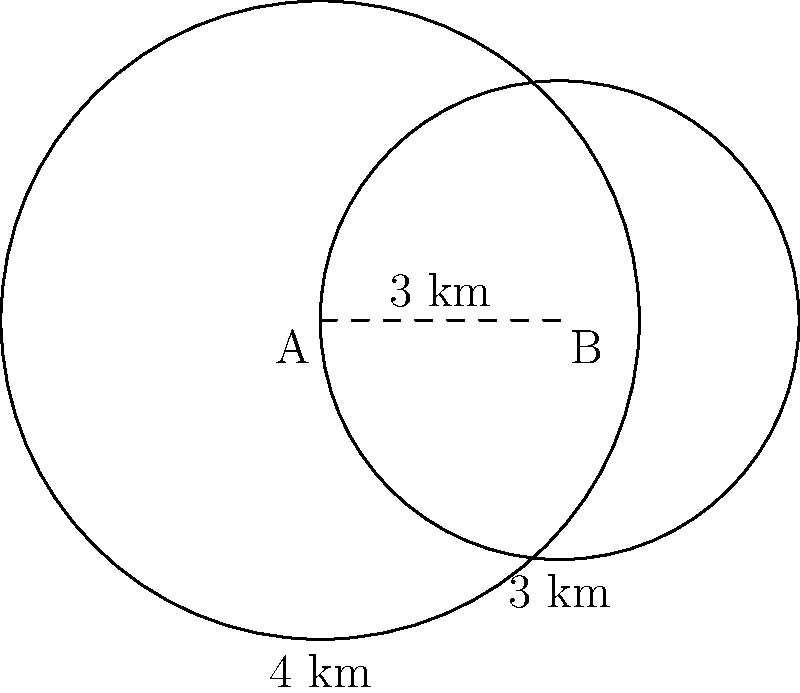Two popular pizza places, A and B, have circular delivery zones with radii of 4 km and 3 km respectively. The centers of these zones are 3 km apart. As a pizza enthusiast exploring different options, you're curious about the area where customers can choose between both pizzerias for delivery. What is the area of the overlapping region between these two delivery zones? To find the area of overlap between two intersecting circles, we can use the following steps:

1) First, we need to calculate the distance $d$ between the centers of the circles. We're given that $d = 3$ km.

2) The radii of the circles are $r_1 = 4$ km and $r_2 = 3$ km.

3) We can use the formula for the area of intersection of two circles:

   $$A = r_1^2 \arccos\left(\frac{d^2 + r_1^2 - r_2^2}{2dr_1}\right) + r_2^2 \arccos\left(\frac{d^2 + r_2^2 - r_1^2}{2dr_2}\right) - \frac{1}{2}\sqrt{(-d+r_1+r_2)(d+r_1-r_2)(d-r_1+r_2)(d+r_1+r_2)}$$

4) Let's substitute our values:

   $$A = 4^2 \arccos\left(\frac{3^2 + 4^2 - 3^2}{2 \cdot 3 \cdot 4}\right) + 3^2 \arccos\left(\frac{3^2 + 3^2 - 4^2}{2 \cdot 3 \cdot 3}\right) - \frac{1}{2}\sqrt{(-3+4+3)(3+4-3)(3-4+3)(3+4+3)}$$

5) Simplifying:

   $$A = 16 \arccos\left(\frac{16}{24}\right) + 9 \arccos\left(\frac{2}{18}\right) - \frac{1}{2}\sqrt{4 \cdot 4 \cdot 2 \cdot 10}$$

6) Calculate:

   $$A \approx 16 \cdot 0.7297 + 9 \cdot 1.4706 - \frac{1}{2}\sqrt{320}$$
   $$A \approx 11.6752 + 13.2354 - 8.9443$$
   $$A \approx 15.9663 \text{ km}^2$$

Therefore, the area of overlap is approximately 15.97 km².
Answer: 15.97 km² 